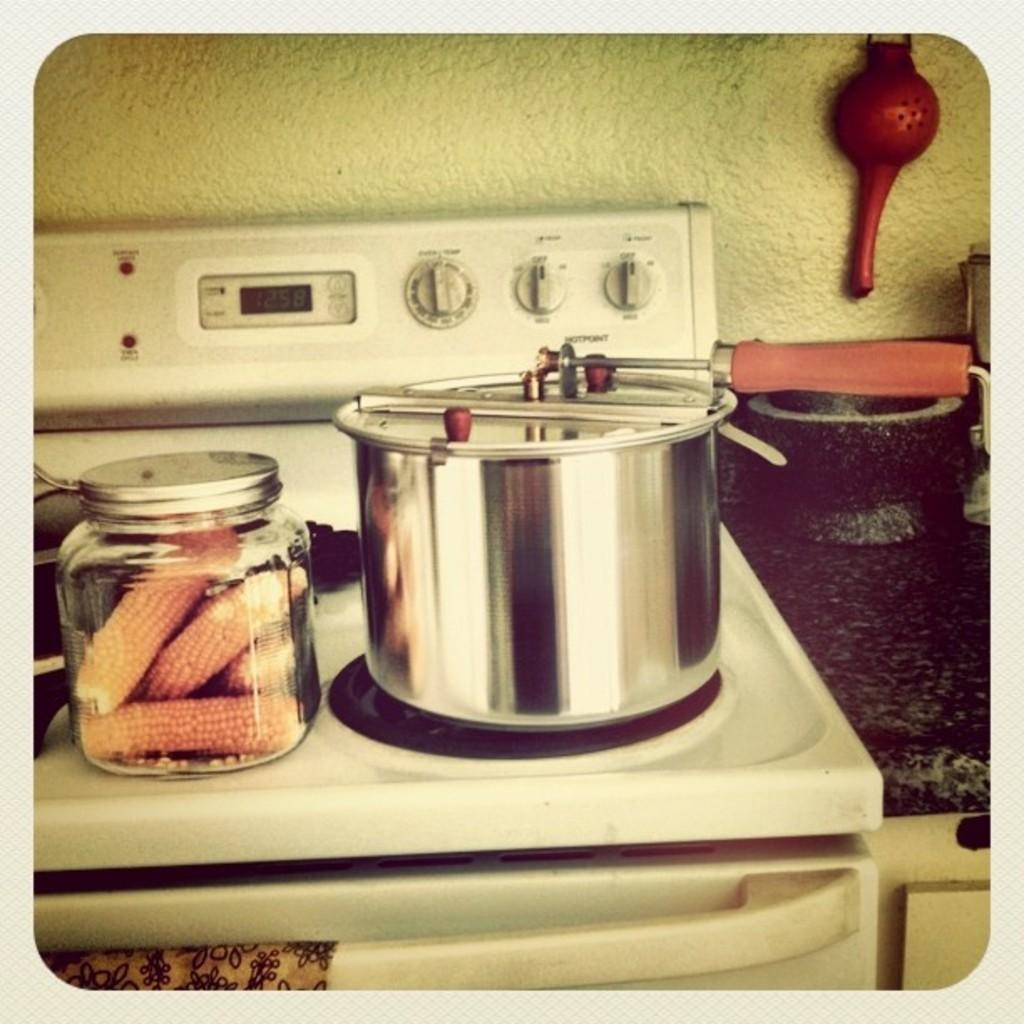<image>
Write a terse but informative summary of the picture. A stove with the time of 12:58 displayed 